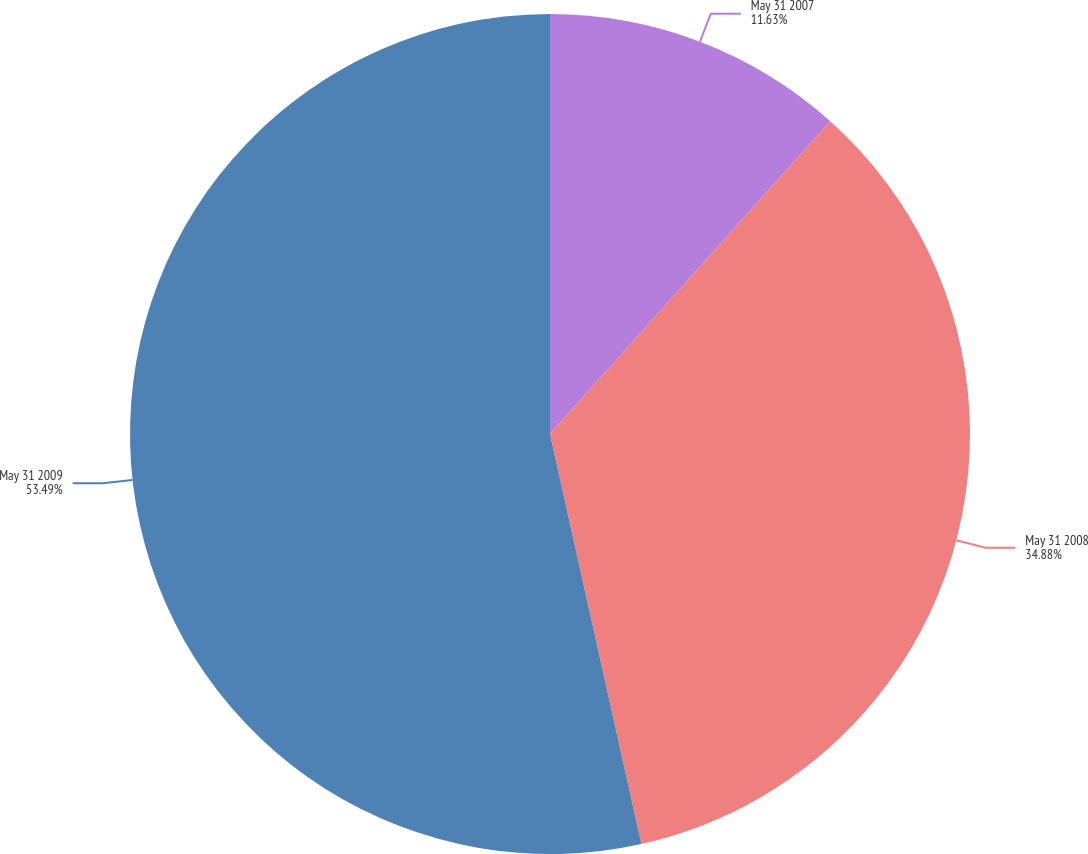<chart> <loc_0><loc_0><loc_500><loc_500><pie_chart><fcel>May 31 2007<fcel>May 31 2008<fcel>May 31 2009<nl><fcel>11.63%<fcel>34.88%<fcel>53.49%<nl></chart> 